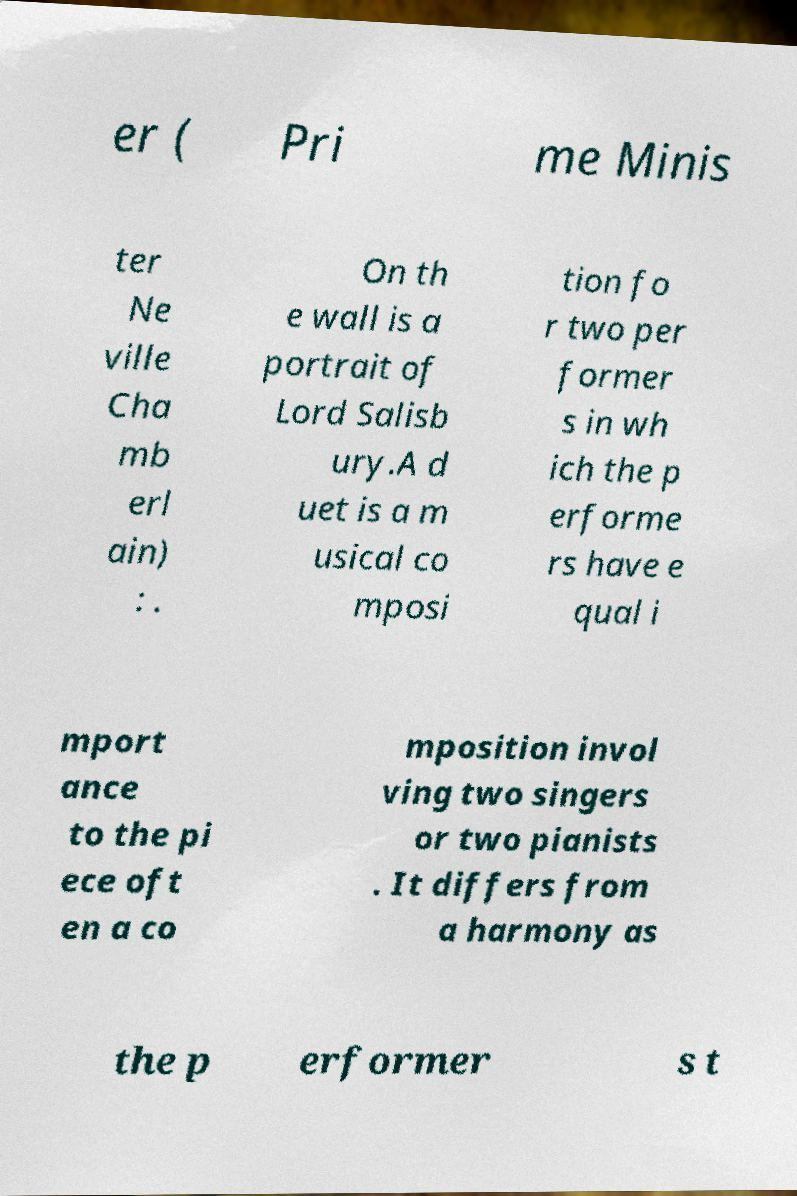Can you read and provide the text displayed in the image?This photo seems to have some interesting text. Can you extract and type it out for me? er ( Pri me Minis ter Ne ville Cha mb erl ain) : . On th e wall is a portrait of Lord Salisb ury.A d uet is a m usical co mposi tion fo r two per former s in wh ich the p erforme rs have e qual i mport ance to the pi ece oft en a co mposition invol ving two singers or two pianists . It differs from a harmony as the p erformer s t 